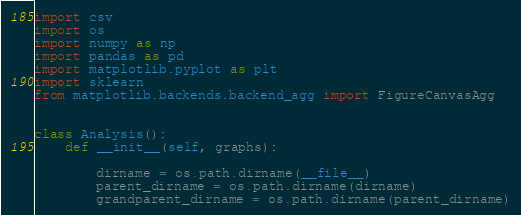Convert code to text. <code><loc_0><loc_0><loc_500><loc_500><_Python_>import csv
import os
import numpy as np
import pandas as pd
import matplotlib.pyplot as plt
import sklearn
from matplotlib.backends.backend_agg import FigureCanvasAgg


class Analysis():
    def __init__(self, graphs):

        dirname = os.path.dirname(__file__)
        parent_dirname = os.path.dirname(dirname)
        grandparent_dirname = os.path.dirname(parent_dirname)</code> 